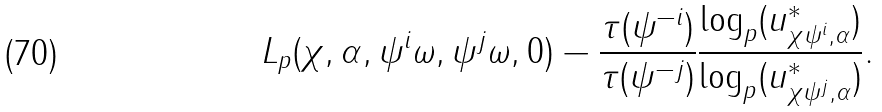Convert formula to latex. <formula><loc_0><loc_0><loc_500><loc_500>L _ { p } ( \chi , \alpha , \psi ^ { i } \omega , \psi ^ { j } \omega , 0 ) - \frac { \tau ( \psi ^ { - i } ) } { \tau ( \psi ^ { - j } ) } \frac { \log _ { p } ( u _ { \chi \psi ^ { i } , \alpha } ^ { * } ) } { \log _ { p } ( u _ { \chi \psi ^ { j } , \alpha } ^ { * } ) } .</formula> 